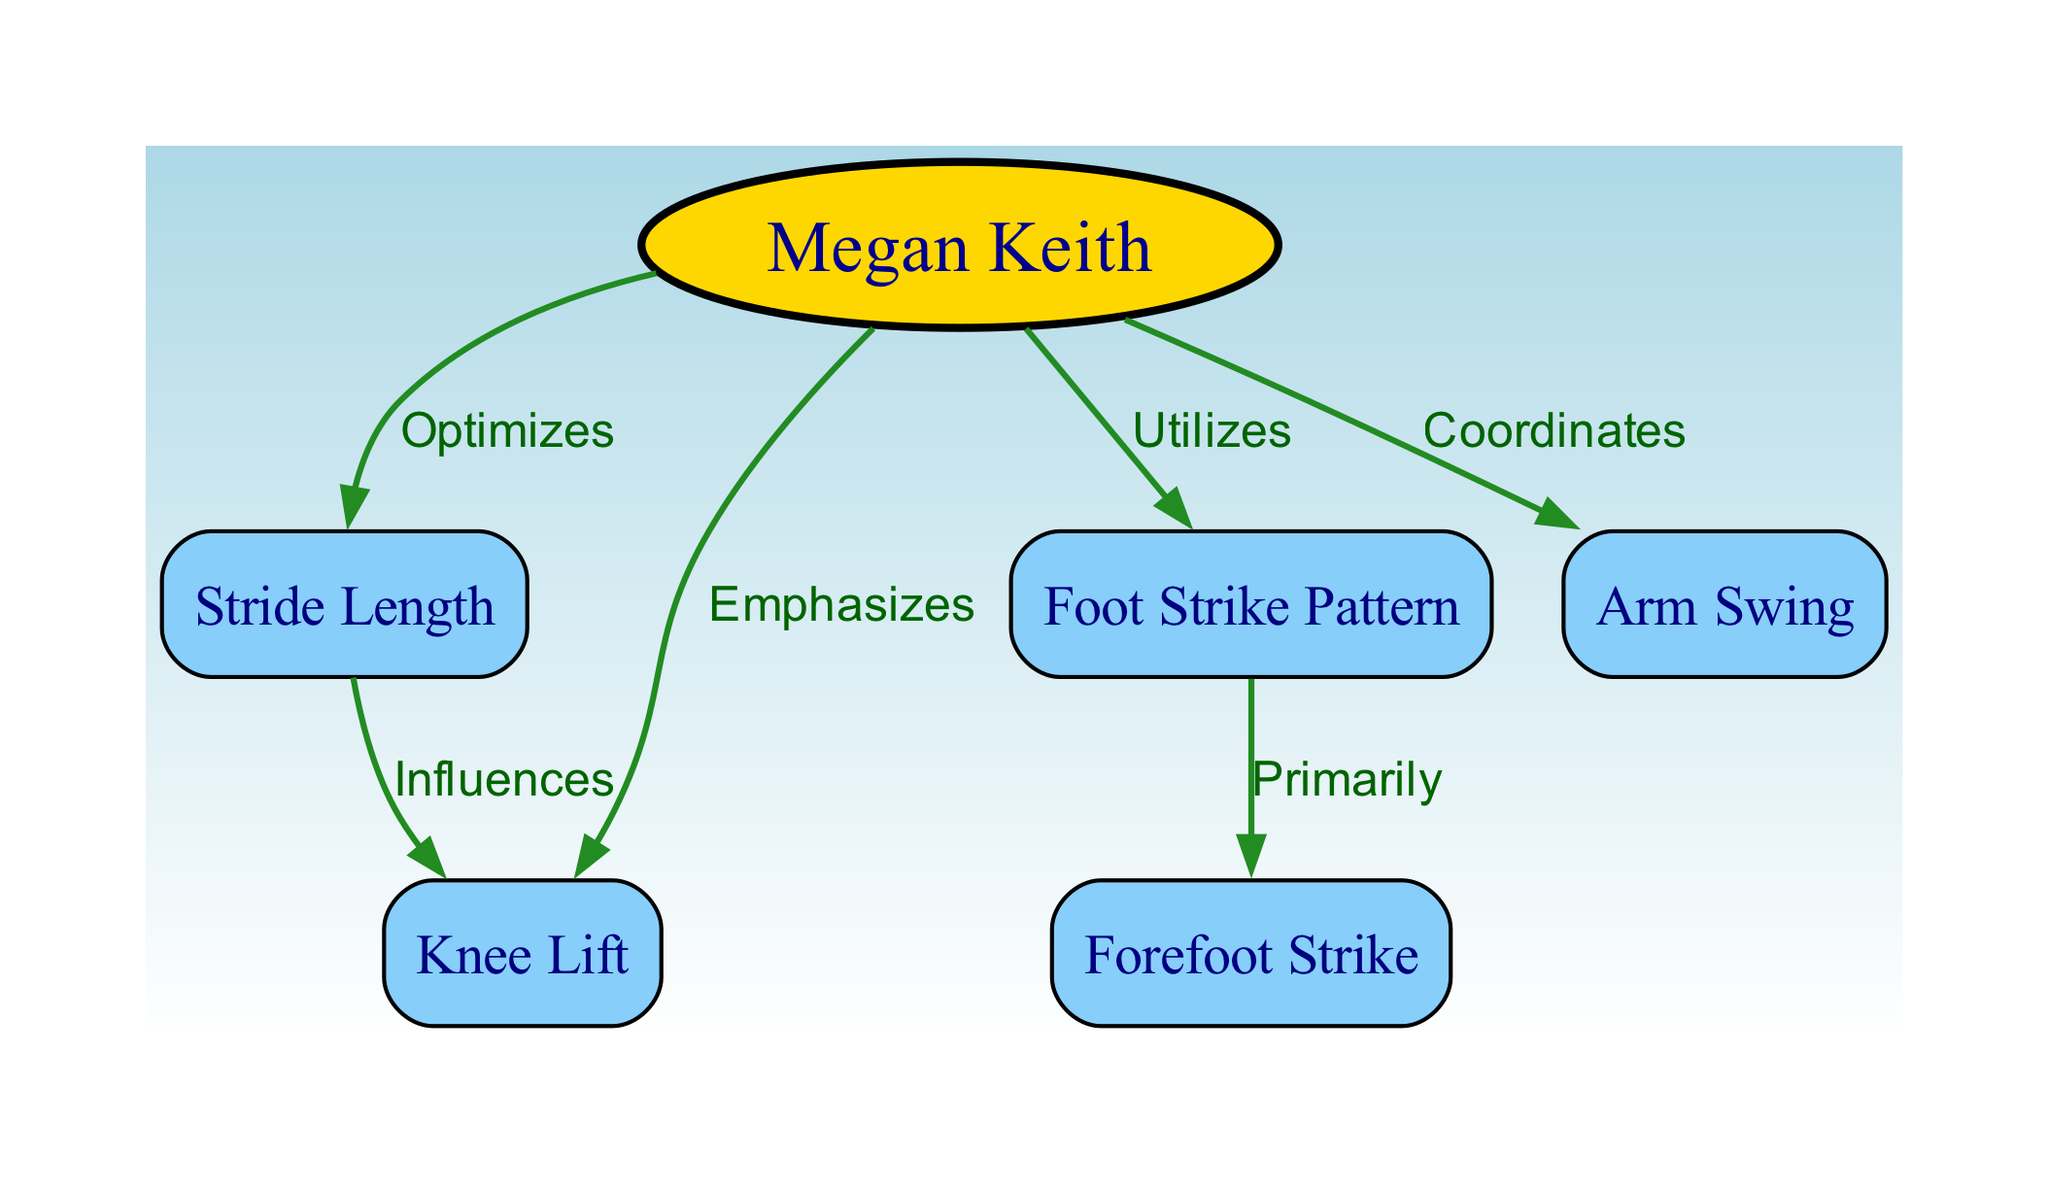What is the main technique Megan Keith utilizes while running? The diagram indicates the relationship where Megan Keith uses the "Foot Strike Pattern" as a primary method in her running technique, showing that it is a key aspect of her biomechanics.
Answer: Foot Strike Pattern How many types of foot strike patterns are specified in the diagram? In the diagram, there is one specific type of foot strike pattern detailed, which is the "Forefoot Strike." This shows the primary classification of her foot strike mechanism.
Answer: One What does Megan Keith emphasize to enhance her running technique? The diagram exemplifies that Megan Keith emphasizes "Knee Lift," indicating its significance in her running biomechanics and how it contributes to her overall performance.
Answer: Knee Lift What does the "Knee Lift" influence according to the diagram? The diagram shows that "Stride Length" is influenced by the "Knee Lift." This indicates that her knee lifting technique directly impacts how far she strides while running.
Answer: Stride Length Which aspect of running does Megan Keith coordinate alongside her overall technique? According to the diagram, "Arm Swing" is the aspect that Megan Keith coordinates, suggesting it plays a complementary role in her running mechanics when she runs.
Answer: Arm Swing How does Megan Keith optimize her running performance? The diagram states that she optimizes her "Stride Length," demonstrating that this optimization is a key factor in improving her efficiency during running.
Answer: Stride Length What is the relationship between "Stride Length" and "Knee Lift"? The diagram establishes that the "Stride Length" is influenced by the "Knee Lift," signifying that her knee lift technique is pivotal for determining the length of her strides.
Answer: Influences Which foot strike pattern does Megan Keith primarily use? The diagram clearly denotes "Forefoot Strike" as the primary foot strike pattern utilized by Megan Keith while running. This shows her preferred technique for foot contact during a stride.
Answer: Forefoot Strike 